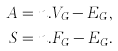Convert formula to latex. <formula><loc_0><loc_0><loc_500><loc_500>A & = n . V _ { G } - E _ { G } , \\ S & = n . F _ { G } - E _ { G } .</formula> 